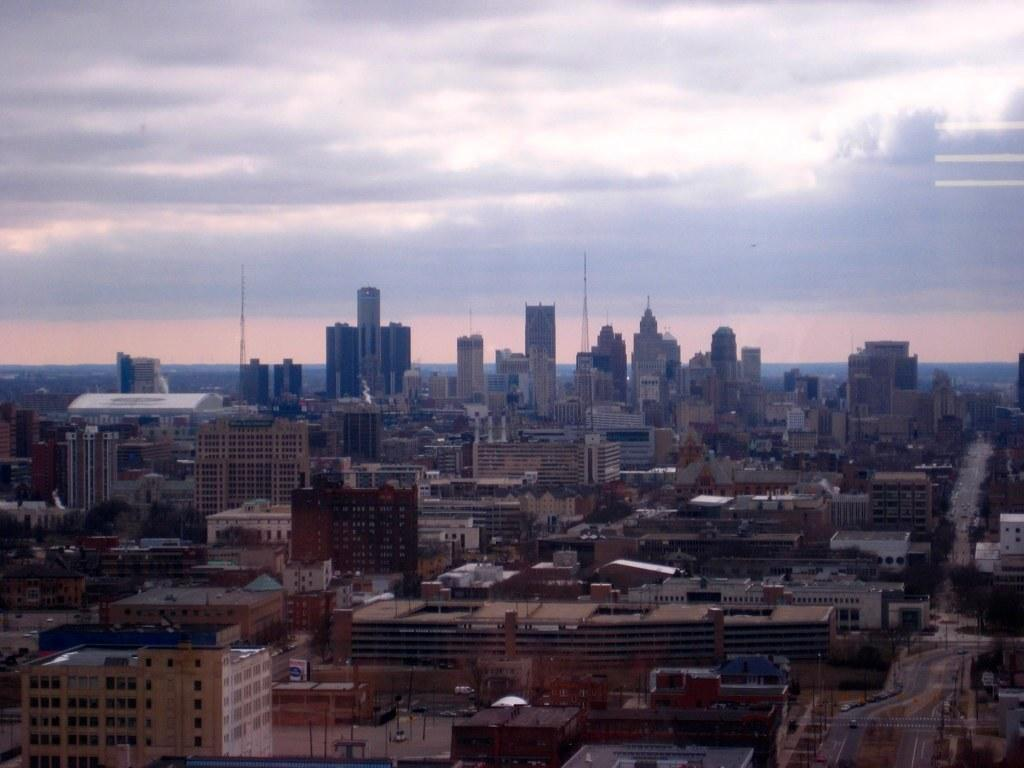What type of structures can be seen in the image? There are buildings in the image. What other natural elements are present in the image? There are trees in the image. What type of transportation infrastructure is visible? There are roads in the image. Are there any indications of current events or activities in the image? Yes, there are current polls in the image. What type of vehicles can be seen in the image? There are vehicles in the image. What can be seen in the background of the image? The sky is visible in the background of the image, and there are clouds present. Can you see the donkey's ear in the image? There is no donkey present in the image, so it is not possible to see its ear. How many tails are visible on the vehicles in the image? The image does not show the tails of the vehicles, so it is not possible to determine their number. 